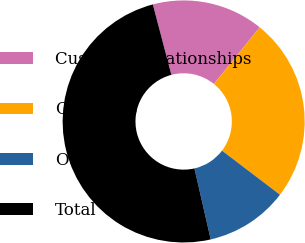Convert chart. <chart><loc_0><loc_0><loc_500><loc_500><pie_chart><fcel>Customer relationships<fcel>Contracts<fcel>Other<fcel>Total<nl><fcel>14.91%<fcel>24.54%<fcel>11.06%<fcel>49.49%<nl></chart> 